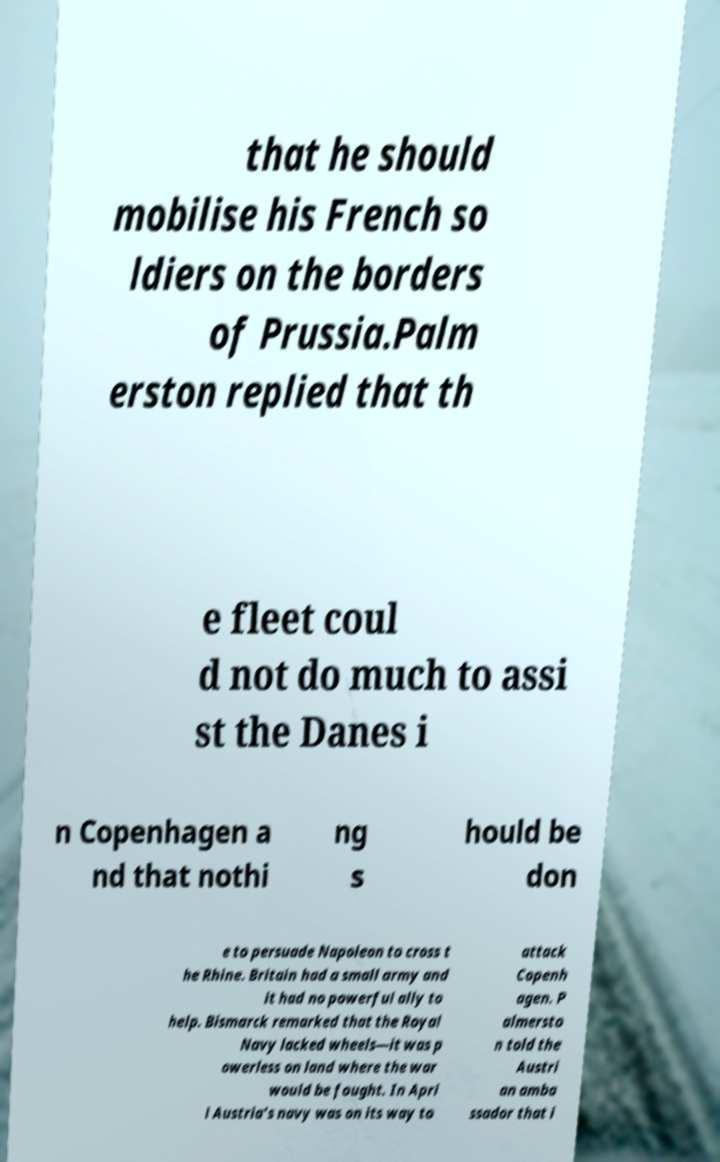There's text embedded in this image that I need extracted. Can you transcribe it verbatim? that he should mobilise his French so ldiers on the borders of Prussia.Palm erston replied that th e fleet coul d not do much to assi st the Danes i n Copenhagen a nd that nothi ng s hould be don e to persuade Napoleon to cross t he Rhine. Britain had a small army and it had no powerful ally to help. Bismarck remarked that the Royal Navy lacked wheels—it was p owerless on land where the war would be fought. In Apri l Austria's navy was on its way to attack Copenh agen. P almersto n told the Austri an amba ssador that i 